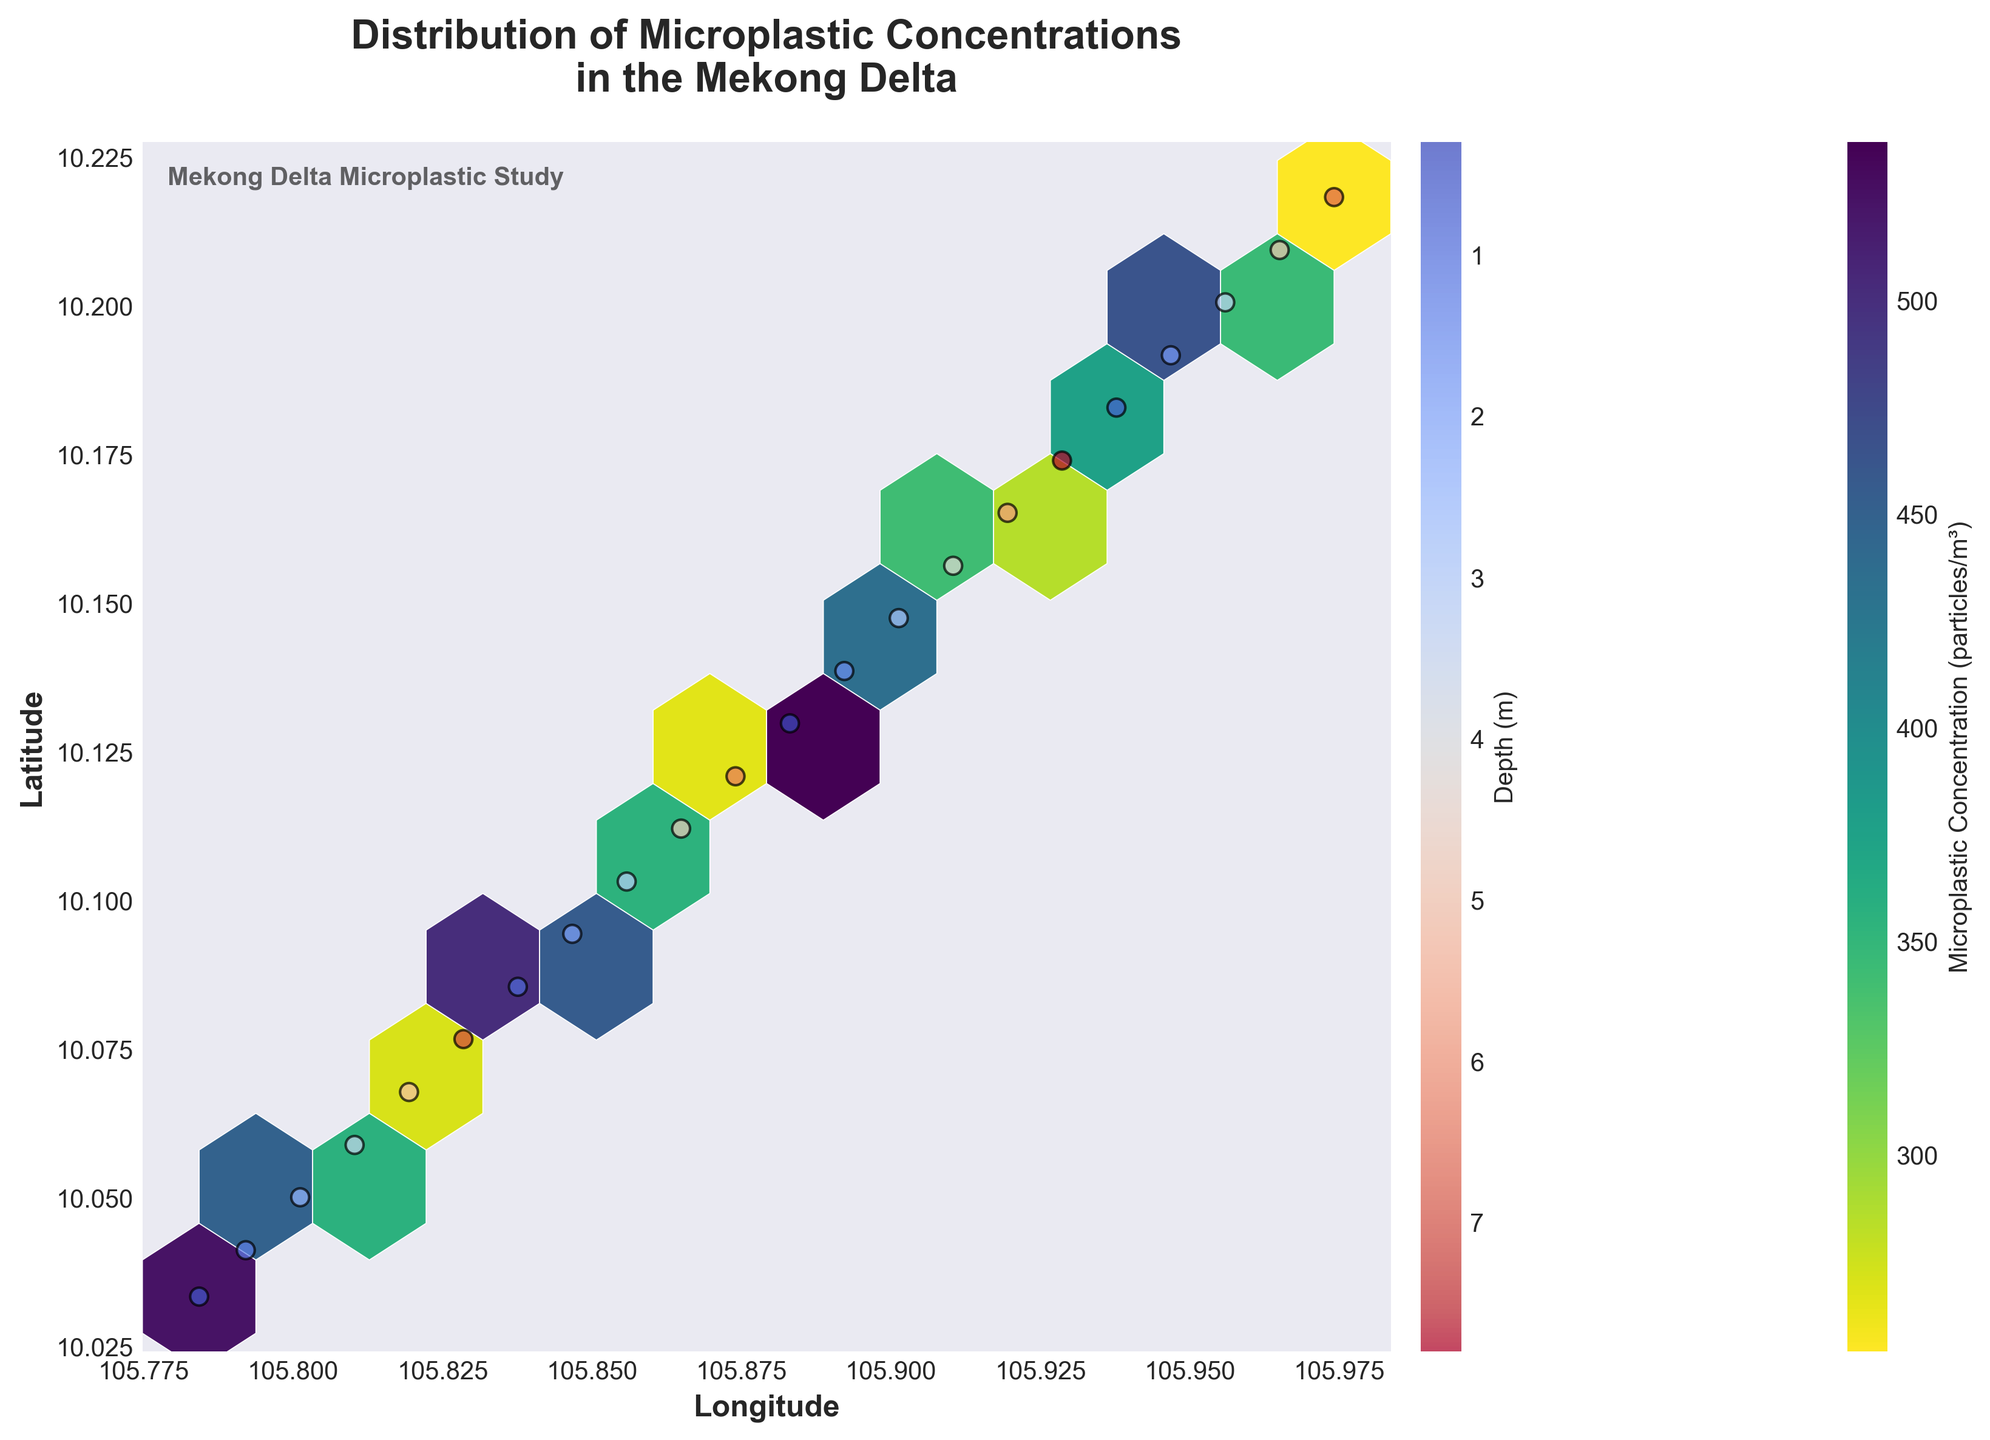What's the title of the figure? The title of the figure is displayed at the top of the plot and reads: "Distribution of Microplastic Concentrations in the Mekong Delta".
Answer: Distribution of Microplastic Concentrations in the Mekong Delta What does the color of the hexagons represent? The color of the hexagons represents the microplastic concentration in particles per cubic meter, as indicated by the color bar labeled "Microplastic Concentration (particles/m³)".
Answer: Microplastic concentration What does the color of the scatter points represent? The color of the scatter points corresponds to the depth in meters, as indicated by the color bar labeled "Depth (m)", and the warmer colors indicate shallower depths, while cooler colors indicate deeper depths.
Answer: Depth (m) Which hexagon indicates the highest concentration of microplastic particles? The hexagon with the darkest color in the "viridis_r" colormap represents the highest concentration of microplastic particles. By visually inspecting the plot, this is a hexagon located roughly around the coordinates with the highest density of dark color.
Answer: Hexagon with the darkest color How do latitudes near 10.03 correlate with microplastic concentrations? By observing the concentration color scale and the latitude axis, locations near 10.03 latitude have hexagons in the darker color range, indicating higher concentrations of microplastic particles.
Answer: Higher concentrations Which longitude and latitude coordinates show the maximum microplastic concentration? By finding the scatter points that overlap with the darkest hexagon, we can determine the coordinates. The plot shows that the coordinates around longitude 105.7843 and latitude 10.0334 have high concentrations.
Answer: Around 105.7843, 10.0334 Is there a trend in microplastic concentration as the depth increases? Observing the scatter points, which are colored by depth, and their corresponding hexagon colors, we see that shallower depths (warmer colors) are often associated with higher hexagon concentrations, suggesting higher microplastic concentrations at shallower depths.
Answer: Higher concentrations at shallower depths What are the longitude and latitude ranges shown in the figure? By looking at the x-axis and y-axis limits, the figure shows longitudes ranging from approximately 105.78 to 105.92 and latitudes ranging from approximately 10.03 to 10.21.
Answer: Longitudes 105.78 to 105.92, latitudes 10.03 to 10.21 Comparing two depths, 0.5 meters and 5.1 meters, which one shows higher microplastic concentrations? The scatter points introduce that 0.5 meters depth (warmer colors) tend to be associated with darker hexagons compared to 5.1 meters depth (cooler colors). Thus, 0.5 meters shows higher concentrations.
Answer: 0.5 meters What's the most common microplastic concentration range across all depths? The most common concentration can be inferred by the most frequently appearing color of the hexagons in the plot. Mid-range colors in viridis_r color map imply mid-range concentrations are the most common.
Answer: Mid-range 